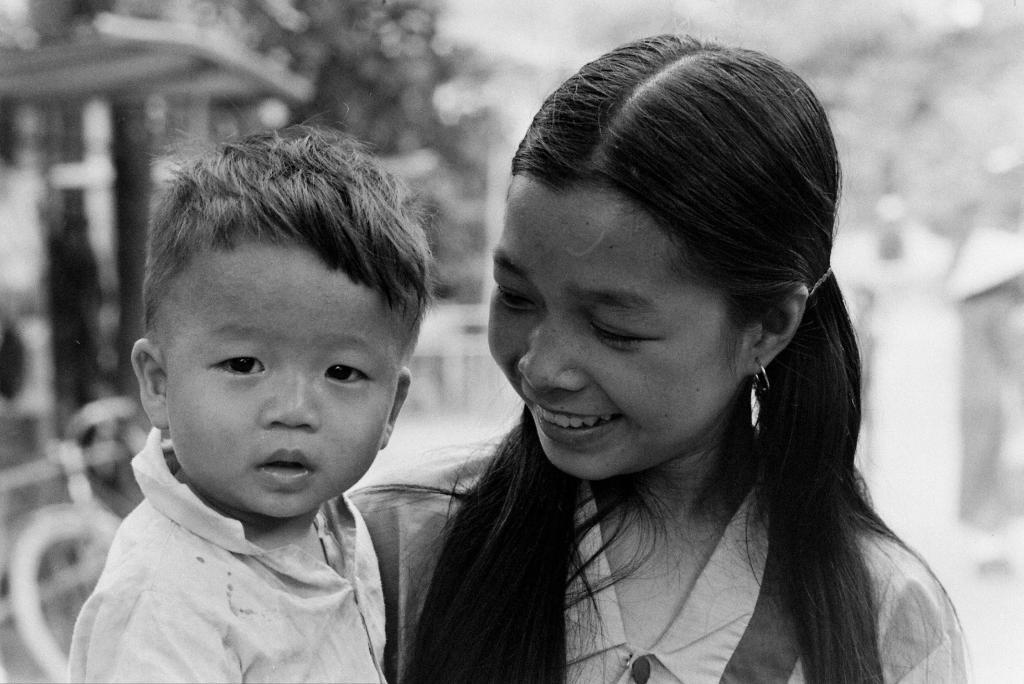How many people are present in the image? There are two people in the image. What is the girl wearing in the image? The girl is wearing a white dress in the image. What is the girl doing with the kid? The girl is holding the kid in the image. Can you describe the background of the image? The background is blurred in the image. What can be seen on the left side of the image? There is a cycle on the left side of the image. What type of birthday celebration is taking place in the image? There is no indication of a birthday celebration in the image. What is the health status of the people in the image? The health status of the people in the image cannot be determined from the image itself. 